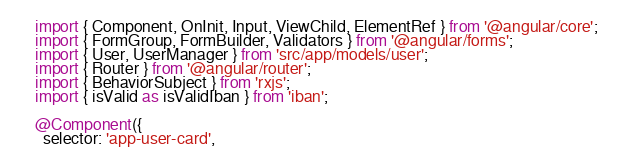Convert code to text. <code><loc_0><loc_0><loc_500><loc_500><_TypeScript_>import { Component, OnInit, Input, ViewChild, ElementRef } from '@angular/core';
import { FormGroup, FormBuilder, Validators } from '@angular/forms';
import { User, UserManager } from 'src/app/models/user';
import { Router } from '@angular/router';
import { BehaviorSubject } from 'rxjs';
import { isValid as isValidIban } from 'iban';

@Component({
  selector: 'app-user-card',</code> 